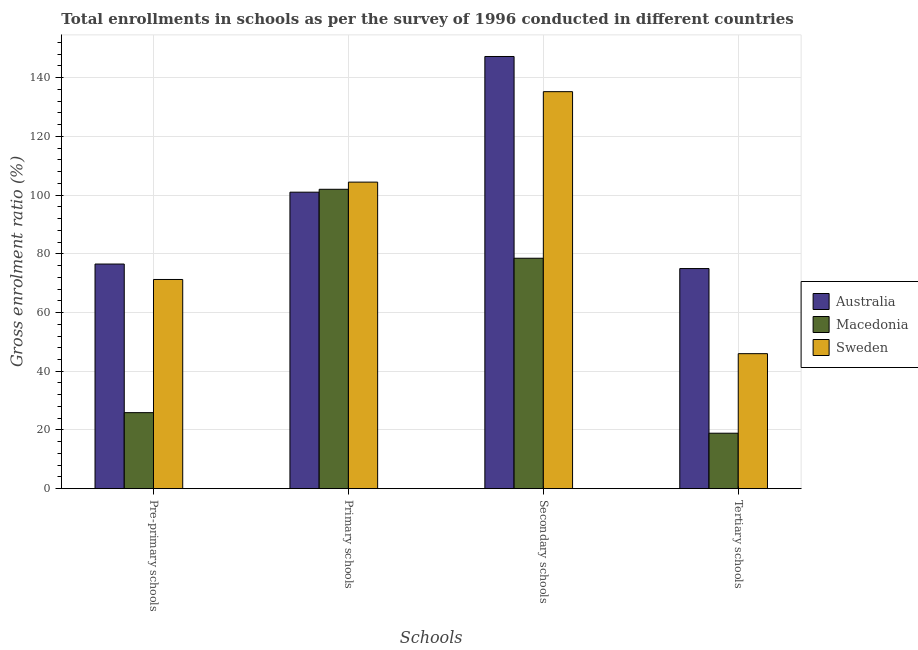Are the number of bars on each tick of the X-axis equal?
Your response must be concise. Yes. How many bars are there on the 2nd tick from the left?
Give a very brief answer. 3. What is the label of the 3rd group of bars from the left?
Provide a short and direct response. Secondary schools. What is the gross enrolment ratio in primary schools in Macedonia?
Provide a succinct answer. 101.98. Across all countries, what is the maximum gross enrolment ratio in secondary schools?
Offer a very short reply. 147.22. Across all countries, what is the minimum gross enrolment ratio in pre-primary schools?
Your answer should be compact. 25.9. In which country was the gross enrolment ratio in primary schools maximum?
Your answer should be compact. Sweden. What is the total gross enrolment ratio in tertiary schools in the graph?
Offer a very short reply. 139.87. What is the difference between the gross enrolment ratio in tertiary schools in Macedonia and that in Sweden?
Offer a very short reply. -27.09. What is the difference between the gross enrolment ratio in tertiary schools in Sweden and the gross enrolment ratio in pre-primary schools in Australia?
Keep it short and to the point. -30.53. What is the average gross enrolment ratio in primary schools per country?
Offer a terse response. 102.47. What is the difference between the gross enrolment ratio in tertiary schools and gross enrolment ratio in secondary schools in Australia?
Give a very brief answer. -72.24. In how many countries, is the gross enrolment ratio in tertiary schools greater than 136 %?
Provide a short and direct response. 0. What is the ratio of the gross enrolment ratio in primary schools in Macedonia to that in Sweden?
Offer a very short reply. 0.98. Is the gross enrolment ratio in primary schools in Australia less than that in Sweden?
Make the answer very short. Yes. What is the difference between the highest and the second highest gross enrolment ratio in primary schools?
Your answer should be very brief. 2.44. What is the difference between the highest and the lowest gross enrolment ratio in secondary schools?
Offer a terse response. 68.73. In how many countries, is the gross enrolment ratio in secondary schools greater than the average gross enrolment ratio in secondary schools taken over all countries?
Your response must be concise. 2. Is the sum of the gross enrolment ratio in secondary schools in Macedonia and Australia greater than the maximum gross enrolment ratio in pre-primary schools across all countries?
Your answer should be very brief. Yes. Is it the case that in every country, the sum of the gross enrolment ratio in pre-primary schools and gross enrolment ratio in tertiary schools is greater than the sum of gross enrolment ratio in secondary schools and gross enrolment ratio in primary schools?
Keep it short and to the point. No. What does the 2nd bar from the right in Secondary schools represents?
Your response must be concise. Macedonia. How many bars are there?
Provide a short and direct response. 12. Are all the bars in the graph horizontal?
Give a very brief answer. No. How many countries are there in the graph?
Provide a succinct answer. 3. What is the difference between two consecutive major ticks on the Y-axis?
Ensure brevity in your answer.  20. Does the graph contain any zero values?
Keep it short and to the point. No. Does the graph contain grids?
Give a very brief answer. Yes. Where does the legend appear in the graph?
Give a very brief answer. Center right. How many legend labels are there?
Your response must be concise. 3. What is the title of the graph?
Ensure brevity in your answer.  Total enrollments in schools as per the survey of 1996 conducted in different countries. Does "New Caledonia" appear as one of the legend labels in the graph?
Offer a terse response. No. What is the label or title of the X-axis?
Provide a short and direct response. Schools. What is the Gross enrolment ratio (%) of Australia in Pre-primary schools?
Keep it short and to the point. 76.52. What is the Gross enrolment ratio (%) of Macedonia in Pre-primary schools?
Offer a very short reply. 25.9. What is the Gross enrolment ratio (%) of Sweden in Pre-primary schools?
Keep it short and to the point. 71.26. What is the Gross enrolment ratio (%) of Australia in Primary schools?
Keep it short and to the point. 101. What is the Gross enrolment ratio (%) of Macedonia in Primary schools?
Ensure brevity in your answer.  101.98. What is the Gross enrolment ratio (%) of Sweden in Primary schools?
Your answer should be very brief. 104.43. What is the Gross enrolment ratio (%) in Australia in Secondary schools?
Give a very brief answer. 147.22. What is the Gross enrolment ratio (%) of Macedonia in Secondary schools?
Your answer should be very brief. 78.5. What is the Gross enrolment ratio (%) in Sweden in Secondary schools?
Offer a terse response. 135.24. What is the Gross enrolment ratio (%) in Australia in Tertiary schools?
Keep it short and to the point. 74.98. What is the Gross enrolment ratio (%) in Macedonia in Tertiary schools?
Give a very brief answer. 18.9. What is the Gross enrolment ratio (%) of Sweden in Tertiary schools?
Your response must be concise. 45.99. Across all Schools, what is the maximum Gross enrolment ratio (%) in Australia?
Provide a succinct answer. 147.22. Across all Schools, what is the maximum Gross enrolment ratio (%) in Macedonia?
Your answer should be very brief. 101.98. Across all Schools, what is the maximum Gross enrolment ratio (%) in Sweden?
Provide a short and direct response. 135.24. Across all Schools, what is the minimum Gross enrolment ratio (%) of Australia?
Provide a short and direct response. 74.98. Across all Schools, what is the minimum Gross enrolment ratio (%) of Macedonia?
Offer a terse response. 18.9. Across all Schools, what is the minimum Gross enrolment ratio (%) of Sweden?
Offer a terse response. 45.99. What is the total Gross enrolment ratio (%) of Australia in the graph?
Your response must be concise. 399.72. What is the total Gross enrolment ratio (%) of Macedonia in the graph?
Make the answer very short. 225.28. What is the total Gross enrolment ratio (%) of Sweden in the graph?
Your response must be concise. 356.92. What is the difference between the Gross enrolment ratio (%) of Australia in Pre-primary schools and that in Primary schools?
Make the answer very short. -24.48. What is the difference between the Gross enrolment ratio (%) in Macedonia in Pre-primary schools and that in Primary schools?
Offer a very short reply. -76.08. What is the difference between the Gross enrolment ratio (%) in Sweden in Pre-primary schools and that in Primary schools?
Your answer should be compact. -33.16. What is the difference between the Gross enrolment ratio (%) in Australia in Pre-primary schools and that in Secondary schools?
Provide a succinct answer. -70.7. What is the difference between the Gross enrolment ratio (%) of Macedonia in Pre-primary schools and that in Secondary schools?
Your response must be concise. -52.6. What is the difference between the Gross enrolment ratio (%) in Sweden in Pre-primary schools and that in Secondary schools?
Provide a succinct answer. -63.98. What is the difference between the Gross enrolment ratio (%) of Australia in Pre-primary schools and that in Tertiary schools?
Make the answer very short. 1.54. What is the difference between the Gross enrolment ratio (%) in Macedonia in Pre-primary schools and that in Tertiary schools?
Your answer should be very brief. 7.01. What is the difference between the Gross enrolment ratio (%) in Sweden in Pre-primary schools and that in Tertiary schools?
Ensure brevity in your answer.  25.27. What is the difference between the Gross enrolment ratio (%) in Australia in Primary schools and that in Secondary schools?
Provide a short and direct response. -46.23. What is the difference between the Gross enrolment ratio (%) in Macedonia in Primary schools and that in Secondary schools?
Offer a very short reply. 23.49. What is the difference between the Gross enrolment ratio (%) of Sweden in Primary schools and that in Secondary schools?
Give a very brief answer. -30.82. What is the difference between the Gross enrolment ratio (%) in Australia in Primary schools and that in Tertiary schools?
Your answer should be compact. 26.02. What is the difference between the Gross enrolment ratio (%) in Macedonia in Primary schools and that in Tertiary schools?
Give a very brief answer. 83.09. What is the difference between the Gross enrolment ratio (%) in Sweden in Primary schools and that in Tertiary schools?
Your answer should be very brief. 58.44. What is the difference between the Gross enrolment ratio (%) in Australia in Secondary schools and that in Tertiary schools?
Give a very brief answer. 72.24. What is the difference between the Gross enrolment ratio (%) of Macedonia in Secondary schools and that in Tertiary schools?
Your answer should be very brief. 59.6. What is the difference between the Gross enrolment ratio (%) of Sweden in Secondary schools and that in Tertiary schools?
Offer a terse response. 89.25. What is the difference between the Gross enrolment ratio (%) in Australia in Pre-primary schools and the Gross enrolment ratio (%) in Macedonia in Primary schools?
Your response must be concise. -25.46. What is the difference between the Gross enrolment ratio (%) of Australia in Pre-primary schools and the Gross enrolment ratio (%) of Sweden in Primary schools?
Ensure brevity in your answer.  -27.91. What is the difference between the Gross enrolment ratio (%) of Macedonia in Pre-primary schools and the Gross enrolment ratio (%) of Sweden in Primary schools?
Your response must be concise. -78.53. What is the difference between the Gross enrolment ratio (%) of Australia in Pre-primary schools and the Gross enrolment ratio (%) of Macedonia in Secondary schools?
Your answer should be very brief. -1.98. What is the difference between the Gross enrolment ratio (%) in Australia in Pre-primary schools and the Gross enrolment ratio (%) in Sweden in Secondary schools?
Your response must be concise. -58.72. What is the difference between the Gross enrolment ratio (%) in Macedonia in Pre-primary schools and the Gross enrolment ratio (%) in Sweden in Secondary schools?
Give a very brief answer. -109.34. What is the difference between the Gross enrolment ratio (%) of Australia in Pre-primary schools and the Gross enrolment ratio (%) of Macedonia in Tertiary schools?
Offer a terse response. 57.62. What is the difference between the Gross enrolment ratio (%) in Australia in Pre-primary schools and the Gross enrolment ratio (%) in Sweden in Tertiary schools?
Provide a short and direct response. 30.53. What is the difference between the Gross enrolment ratio (%) of Macedonia in Pre-primary schools and the Gross enrolment ratio (%) of Sweden in Tertiary schools?
Give a very brief answer. -20.09. What is the difference between the Gross enrolment ratio (%) in Australia in Primary schools and the Gross enrolment ratio (%) in Macedonia in Secondary schools?
Make the answer very short. 22.5. What is the difference between the Gross enrolment ratio (%) in Australia in Primary schools and the Gross enrolment ratio (%) in Sweden in Secondary schools?
Ensure brevity in your answer.  -34.24. What is the difference between the Gross enrolment ratio (%) in Macedonia in Primary schools and the Gross enrolment ratio (%) in Sweden in Secondary schools?
Offer a very short reply. -33.26. What is the difference between the Gross enrolment ratio (%) of Australia in Primary schools and the Gross enrolment ratio (%) of Macedonia in Tertiary schools?
Offer a very short reply. 82.1. What is the difference between the Gross enrolment ratio (%) in Australia in Primary schools and the Gross enrolment ratio (%) in Sweden in Tertiary schools?
Ensure brevity in your answer.  55.01. What is the difference between the Gross enrolment ratio (%) in Macedonia in Primary schools and the Gross enrolment ratio (%) in Sweden in Tertiary schools?
Offer a very short reply. 55.99. What is the difference between the Gross enrolment ratio (%) in Australia in Secondary schools and the Gross enrolment ratio (%) in Macedonia in Tertiary schools?
Ensure brevity in your answer.  128.33. What is the difference between the Gross enrolment ratio (%) of Australia in Secondary schools and the Gross enrolment ratio (%) of Sweden in Tertiary schools?
Your answer should be compact. 101.23. What is the difference between the Gross enrolment ratio (%) in Macedonia in Secondary schools and the Gross enrolment ratio (%) in Sweden in Tertiary schools?
Offer a terse response. 32.51. What is the average Gross enrolment ratio (%) of Australia per Schools?
Your answer should be very brief. 99.93. What is the average Gross enrolment ratio (%) of Macedonia per Schools?
Your response must be concise. 56.32. What is the average Gross enrolment ratio (%) of Sweden per Schools?
Keep it short and to the point. 89.23. What is the difference between the Gross enrolment ratio (%) of Australia and Gross enrolment ratio (%) of Macedonia in Pre-primary schools?
Ensure brevity in your answer.  50.62. What is the difference between the Gross enrolment ratio (%) of Australia and Gross enrolment ratio (%) of Sweden in Pre-primary schools?
Provide a succinct answer. 5.26. What is the difference between the Gross enrolment ratio (%) in Macedonia and Gross enrolment ratio (%) in Sweden in Pre-primary schools?
Your answer should be very brief. -45.36. What is the difference between the Gross enrolment ratio (%) in Australia and Gross enrolment ratio (%) in Macedonia in Primary schools?
Your response must be concise. -0.99. What is the difference between the Gross enrolment ratio (%) of Australia and Gross enrolment ratio (%) of Sweden in Primary schools?
Your answer should be very brief. -3.43. What is the difference between the Gross enrolment ratio (%) of Macedonia and Gross enrolment ratio (%) of Sweden in Primary schools?
Your response must be concise. -2.44. What is the difference between the Gross enrolment ratio (%) of Australia and Gross enrolment ratio (%) of Macedonia in Secondary schools?
Provide a short and direct response. 68.73. What is the difference between the Gross enrolment ratio (%) of Australia and Gross enrolment ratio (%) of Sweden in Secondary schools?
Keep it short and to the point. 11.98. What is the difference between the Gross enrolment ratio (%) of Macedonia and Gross enrolment ratio (%) of Sweden in Secondary schools?
Your answer should be very brief. -56.74. What is the difference between the Gross enrolment ratio (%) of Australia and Gross enrolment ratio (%) of Macedonia in Tertiary schools?
Offer a very short reply. 56.09. What is the difference between the Gross enrolment ratio (%) in Australia and Gross enrolment ratio (%) in Sweden in Tertiary schools?
Ensure brevity in your answer.  28.99. What is the difference between the Gross enrolment ratio (%) of Macedonia and Gross enrolment ratio (%) of Sweden in Tertiary schools?
Offer a very short reply. -27.09. What is the ratio of the Gross enrolment ratio (%) in Australia in Pre-primary schools to that in Primary schools?
Offer a very short reply. 0.76. What is the ratio of the Gross enrolment ratio (%) in Macedonia in Pre-primary schools to that in Primary schools?
Offer a very short reply. 0.25. What is the ratio of the Gross enrolment ratio (%) in Sweden in Pre-primary schools to that in Primary schools?
Make the answer very short. 0.68. What is the ratio of the Gross enrolment ratio (%) in Australia in Pre-primary schools to that in Secondary schools?
Ensure brevity in your answer.  0.52. What is the ratio of the Gross enrolment ratio (%) in Macedonia in Pre-primary schools to that in Secondary schools?
Give a very brief answer. 0.33. What is the ratio of the Gross enrolment ratio (%) of Sweden in Pre-primary schools to that in Secondary schools?
Your response must be concise. 0.53. What is the ratio of the Gross enrolment ratio (%) in Australia in Pre-primary schools to that in Tertiary schools?
Ensure brevity in your answer.  1.02. What is the ratio of the Gross enrolment ratio (%) in Macedonia in Pre-primary schools to that in Tertiary schools?
Your response must be concise. 1.37. What is the ratio of the Gross enrolment ratio (%) in Sweden in Pre-primary schools to that in Tertiary schools?
Provide a short and direct response. 1.55. What is the ratio of the Gross enrolment ratio (%) in Australia in Primary schools to that in Secondary schools?
Your response must be concise. 0.69. What is the ratio of the Gross enrolment ratio (%) in Macedonia in Primary schools to that in Secondary schools?
Your answer should be compact. 1.3. What is the ratio of the Gross enrolment ratio (%) in Sweden in Primary schools to that in Secondary schools?
Keep it short and to the point. 0.77. What is the ratio of the Gross enrolment ratio (%) of Australia in Primary schools to that in Tertiary schools?
Your answer should be very brief. 1.35. What is the ratio of the Gross enrolment ratio (%) in Macedonia in Primary schools to that in Tertiary schools?
Your response must be concise. 5.4. What is the ratio of the Gross enrolment ratio (%) of Sweden in Primary schools to that in Tertiary schools?
Offer a terse response. 2.27. What is the ratio of the Gross enrolment ratio (%) of Australia in Secondary schools to that in Tertiary schools?
Provide a succinct answer. 1.96. What is the ratio of the Gross enrolment ratio (%) in Macedonia in Secondary schools to that in Tertiary schools?
Offer a terse response. 4.15. What is the ratio of the Gross enrolment ratio (%) in Sweden in Secondary schools to that in Tertiary schools?
Give a very brief answer. 2.94. What is the difference between the highest and the second highest Gross enrolment ratio (%) of Australia?
Offer a terse response. 46.23. What is the difference between the highest and the second highest Gross enrolment ratio (%) in Macedonia?
Provide a succinct answer. 23.49. What is the difference between the highest and the second highest Gross enrolment ratio (%) of Sweden?
Make the answer very short. 30.82. What is the difference between the highest and the lowest Gross enrolment ratio (%) in Australia?
Your answer should be very brief. 72.24. What is the difference between the highest and the lowest Gross enrolment ratio (%) in Macedonia?
Make the answer very short. 83.09. What is the difference between the highest and the lowest Gross enrolment ratio (%) of Sweden?
Ensure brevity in your answer.  89.25. 